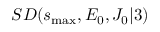Convert formula to latex. <formula><loc_0><loc_0><loc_500><loc_500>S D ( s _ { \max } , E _ { 0 } , J _ { 0 } | 3 )</formula> 